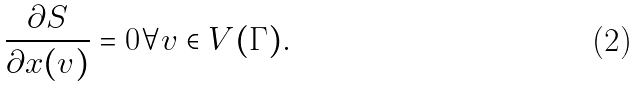<formula> <loc_0><loc_0><loc_500><loc_500>\frac { \partial S } { \partial x ( v ) } = 0 \forall v \in V ( \Gamma ) .</formula> 